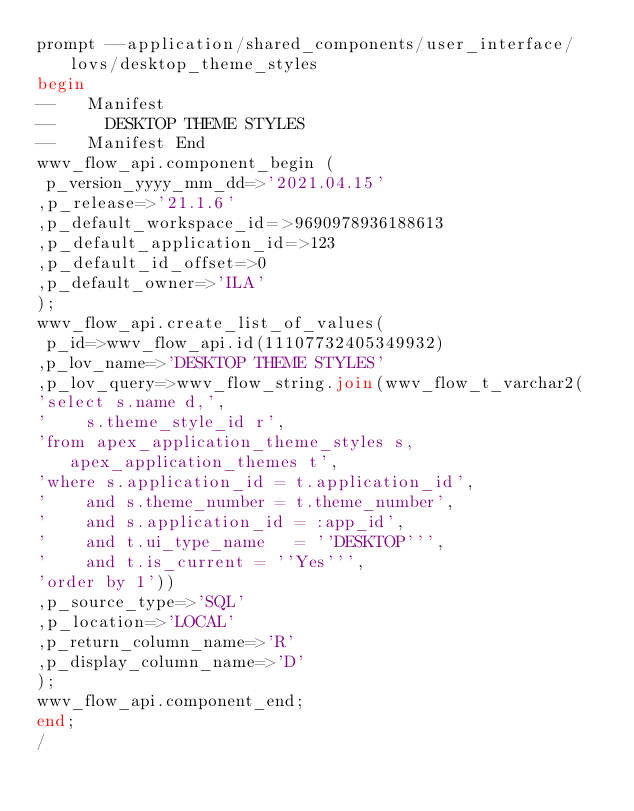Convert code to text. <code><loc_0><loc_0><loc_500><loc_500><_SQL_>prompt --application/shared_components/user_interface/lovs/desktop_theme_styles
begin
--   Manifest
--     DESKTOP THEME STYLES
--   Manifest End
wwv_flow_api.component_begin (
 p_version_yyyy_mm_dd=>'2021.04.15'
,p_release=>'21.1.6'
,p_default_workspace_id=>9690978936188613
,p_default_application_id=>123
,p_default_id_offset=>0
,p_default_owner=>'ILA'
);
wwv_flow_api.create_list_of_values(
 p_id=>wwv_flow_api.id(11107732405349932)
,p_lov_name=>'DESKTOP THEME STYLES'
,p_lov_query=>wwv_flow_string.join(wwv_flow_t_varchar2(
'select s.name d,',
'    s.theme_style_id r',
'from apex_application_theme_styles s, apex_application_themes t',
'where s.application_id = t.application_id',
'    and s.theme_number = t.theme_number',
'    and s.application_id = :app_id',
'    and t.ui_type_name   = ''DESKTOP''',
'    and t.is_current = ''Yes''',
'order by 1'))
,p_source_type=>'SQL'
,p_location=>'LOCAL'
,p_return_column_name=>'R'
,p_display_column_name=>'D'
);
wwv_flow_api.component_end;
end;
/
</code> 